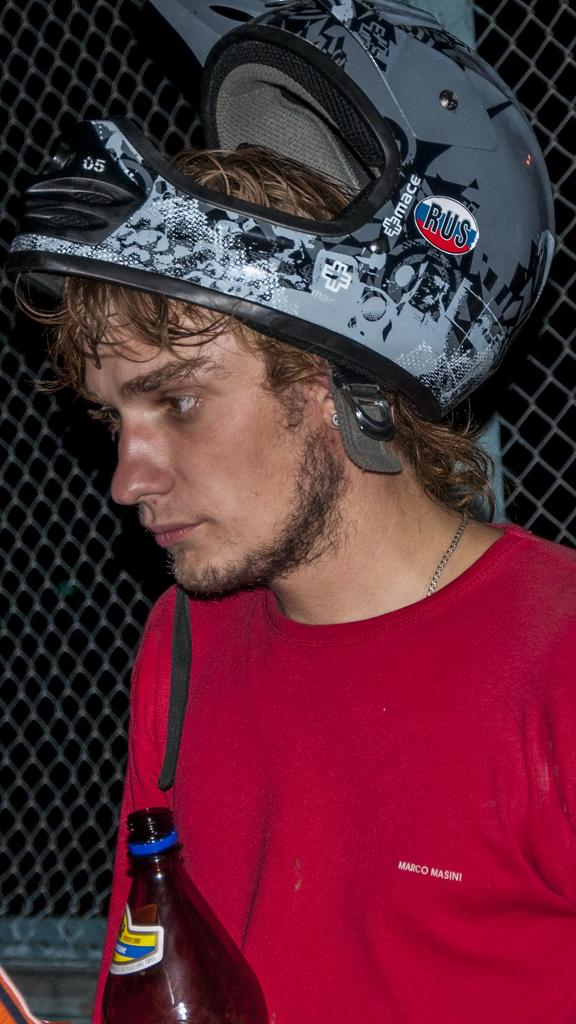Who is present in the image? There is a man in the image. What is the man wearing on his upper body? The man is wearing a red T-shirt. What type of protective gear is the man wearing? The man is wearing a helmet. What object can be seen in the image that is typically used for holding liquids? There is a brown bottle in the image. What type of architectural feature can be seen in the background of the image? There is a fencing gate in the background of the image. What type of furniture is on fire in the image? There is no furniture on fire in the image; it does not depict any flames or burning objects. 